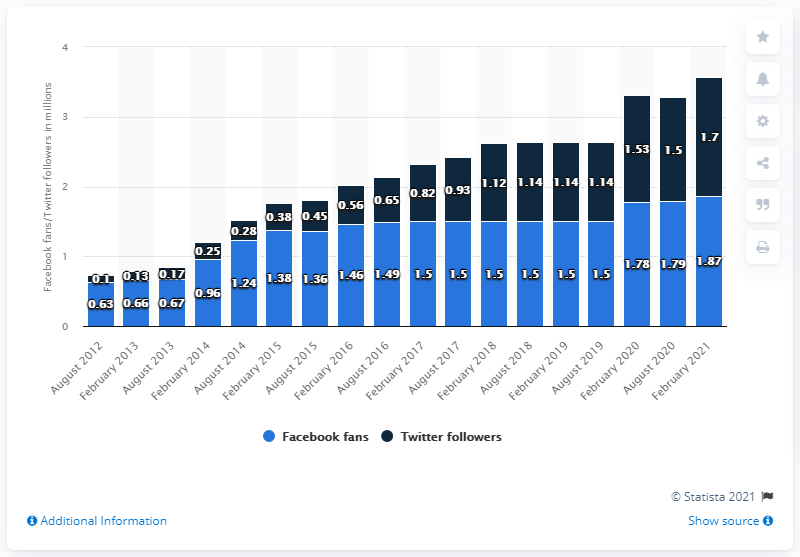Outline some significant characteristics in this image. The Kansas City Chiefs' Facebook page reached 1.87 million on February 2021. The Kansas City Chiefs had their Facebook page last updated in August 2012. As of February 2021, the Kansas City Chiefs football team had approximately 1.87 million fans on their Facebook page. 